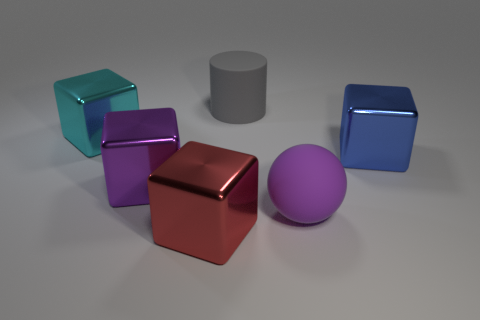Does the big purple matte thing in front of the large purple metallic object have the same shape as the large gray matte thing?
Keep it short and to the point. No. How many large blue things are behind the big purple object on the left side of the big thing that is in front of the large purple rubber thing?
Provide a succinct answer. 1. Is there any other thing that has the same shape as the large gray thing?
Your answer should be very brief. No. What number of objects are either red metallic blocks or large cubes?
Keep it short and to the point. 4. There is a purple shiny thing; is it the same shape as the rubber object in front of the cyan metallic thing?
Provide a succinct answer. No. The purple object to the right of the big red shiny object has what shape?
Give a very brief answer. Sphere. Is the shape of the big cyan metal object the same as the red thing?
Provide a short and direct response. Yes. The blue shiny object that is the same shape as the large purple metallic object is what size?
Ensure brevity in your answer.  Large. There is a matte thing in front of the cyan cube; is it the same size as the purple shiny cube?
Give a very brief answer. Yes. How big is the thing that is behind the purple matte ball and right of the big gray object?
Keep it short and to the point. Large. 